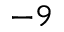<formula> <loc_0><loc_0><loc_500><loc_500>^ { - 9 }</formula> 